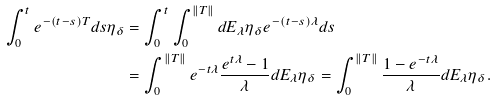<formula> <loc_0><loc_0><loc_500><loc_500>\int _ { 0 } ^ { t } e ^ { - ( t - s ) T } d s \eta _ { \delta } & = \int _ { 0 } ^ { t } \int _ { 0 } ^ { \| T \| } d E _ { \lambda } \eta _ { \delta } e ^ { - ( t - s ) \lambda } d s \\ & = \int _ { 0 } ^ { \| T \| } e ^ { - t \lambda } \frac { e ^ { t \lambda } - 1 } { \lambda } d E _ { \lambda } \eta _ { \delta } = \int _ { 0 } ^ { \| T \| } \frac { 1 - e ^ { - t \lambda } } { \lambda } d E _ { \lambda } \eta _ { \delta } .</formula> 